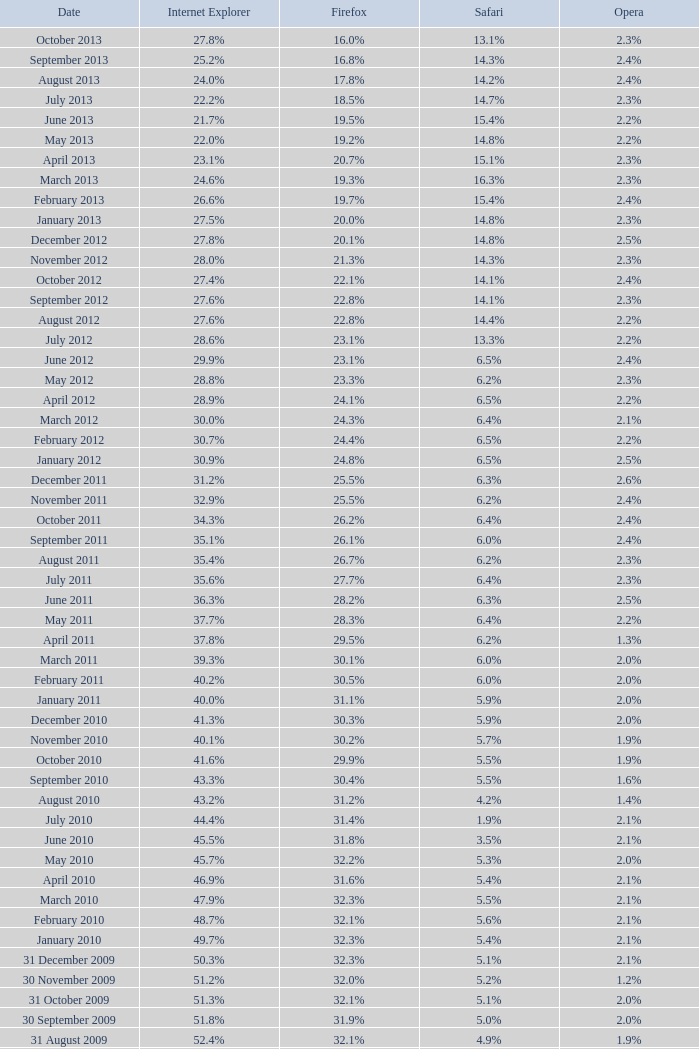With opera at 2.4% and internet explorer at 29.9%, what percentage does safari hold? 6.5%. 